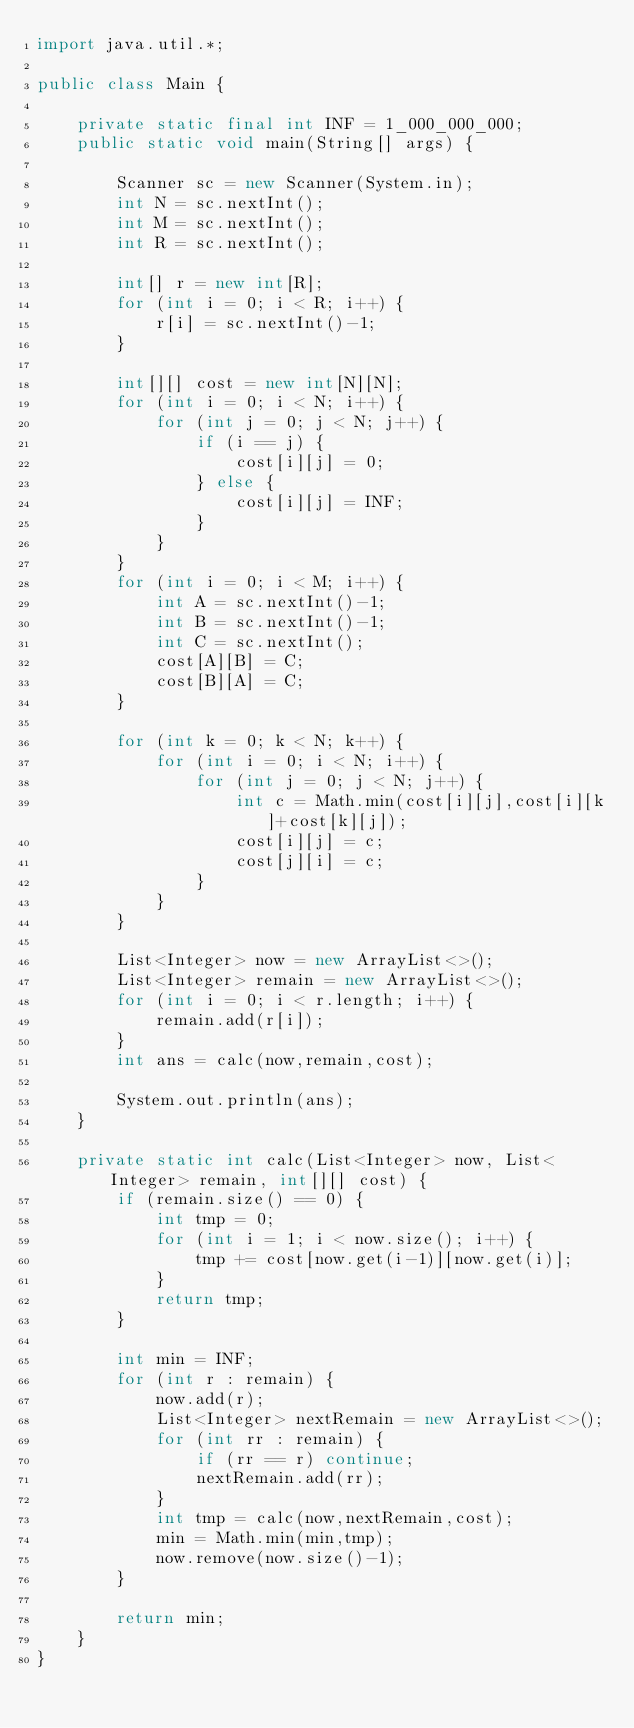<code> <loc_0><loc_0><loc_500><loc_500><_Java_>import java.util.*;

public class Main {

    private static final int INF = 1_000_000_000;
    public static void main(String[] args) {

        Scanner sc = new Scanner(System.in);
        int N = sc.nextInt();
        int M = sc.nextInt();
        int R = sc.nextInt();

        int[] r = new int[R];
        for (int i = 0; i < R; i++) {
            r[i] = sc.nextInt()-1;
        }

        int[][] cost = new int[N][N];
        for (int i = 0; i < N; i++) {
            for (int j = 0; j < N; j++) {
                if (i == j) {
                    cost[i][j] = 0;
                } else {
                    cost[i][j] = INF;
                }
            }
        }
        for (int i = 0; i < M; i++) {
            int A = sc.nextInt()-1;
            int B = sc.nextInt()-1;
            int C = sc.nextInt();
            cost[A][B] = C;
            cost[B][A] = C;
        }

        for (int k = 0; k < N; k++) {
            for (int i = 0; i < N; i++) {
                for (int j = 0; j < N; j++) {
                    int c = Math.min(cost[i][j],cost[i][k]+cost[k][j]);
                    cost[i][j] = c;
                    cost[j][i] = c;
                }
            }
        }

        List<Integer> now = new ArrayList<>();
        List<Integer> remain = new ArrayList<>();
        for (int i = 0; i < r.length; i++) {
            remain.add(r[i]);
        }
        int ans = calc(now,remain,cost);

        System.out.println(ans);
    }

    private static int calc(List<Integer> now, List<Integer> remain, int[][] cost) {
        if (remain.size() == 0) {
            int tmp = 0;
            for (int i = 1; i < now.size(); i++) {
                tmp += cost[now.get(i-1)][now.get(i)];
            }
            return tmp;
        }

        int min = INF;
        for (int r : remain) {
            now.add(r);
            List<Integer> nextRemain = new ArrayList<>();
            for (int rr : remain) {
                if (rr == r) continue;
                nextRemain.add(rr);
            }
            int tmp = calc(now,nextRemain,cost);
            min = Math.min(min,tmp);
            now.remove(now.size()-1);
        }

        return min;
    }
}
</code> 